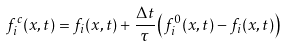<formula> <loc_0><loc_0><loc_500><loc_500>f _ { i } ^ { c } ( { x } , t ) = f _ { i } ( { x } , t ) + \frac { \Delta t } { \tau } \left ( f _ { i } ^ { 0 } ( { x } , t ) - f _ { i } ( { x } , t ) \right )</formula> 